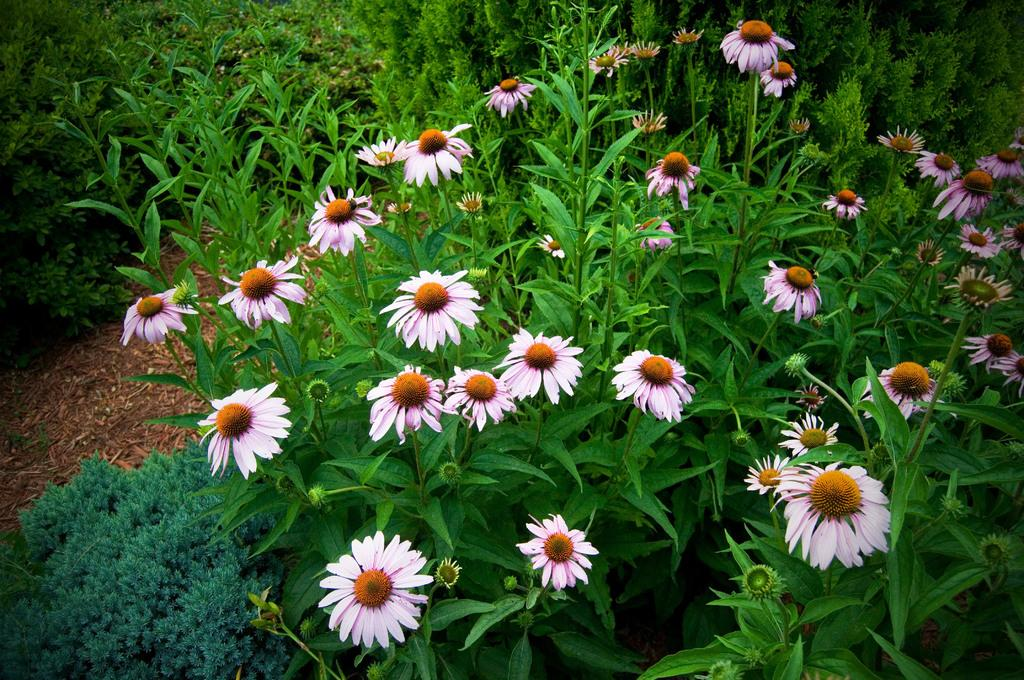What type of decoration can be seen on the plants in the image? There are flowers on the plants in the image. How many other plants can be seen in the image? There are many other plants visible in the image. Can you see a lake in the image? There is no lake present in the image. Are there any kittens wearing stockings in the image? There are no kittens or stockings present in the image. 